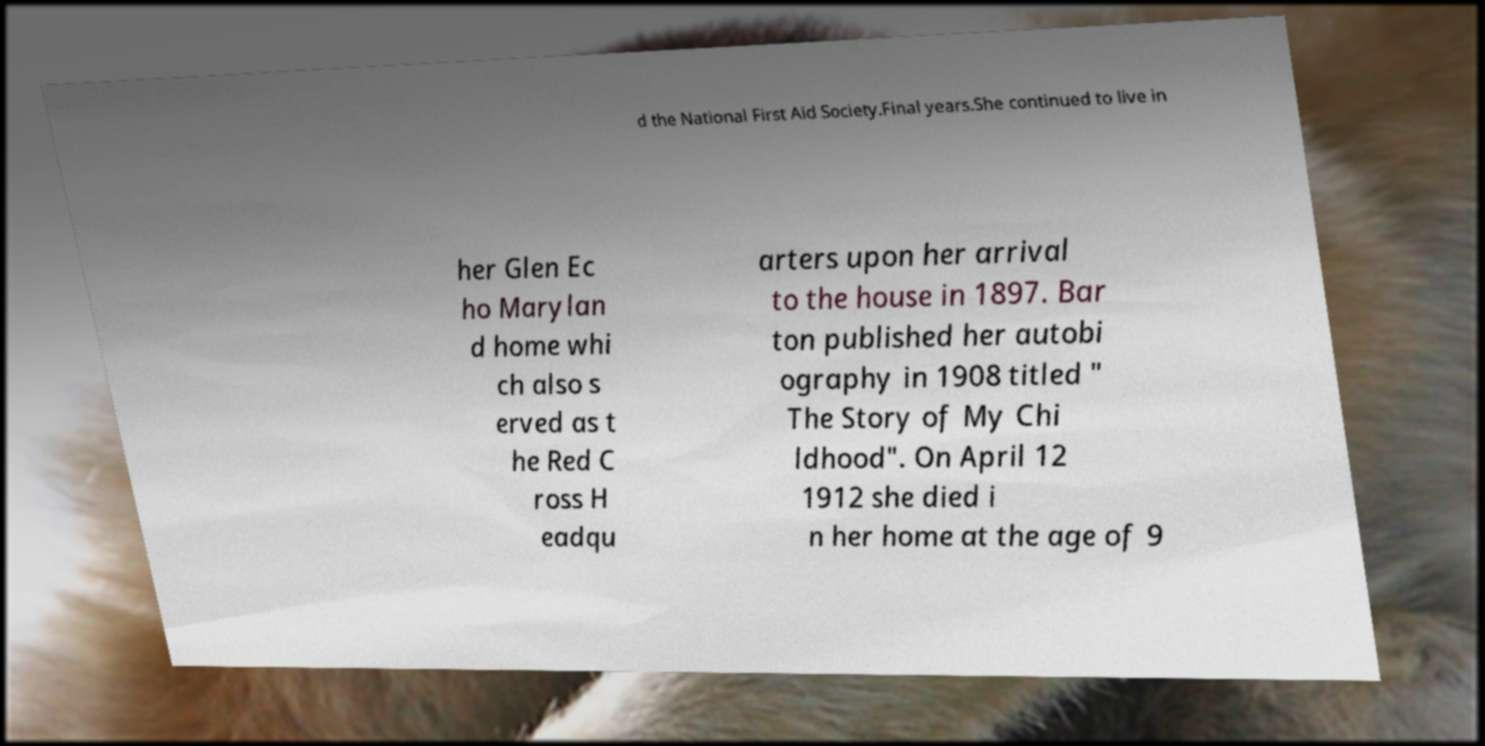Could you assist in decoding the text presented in this image and type it out clearly? d the National First Aid Society.Final years.She continued to live in her Glen Ec ho Marylan d home whi ch also s erved as t he Red C ross H eadqu arters upon her arrival to the house in 1897. Bar ton published her autobi ography in 1908 titled " The Story of My Chi ldhood". On April 12 1912 she died i n her home at the age of 9 